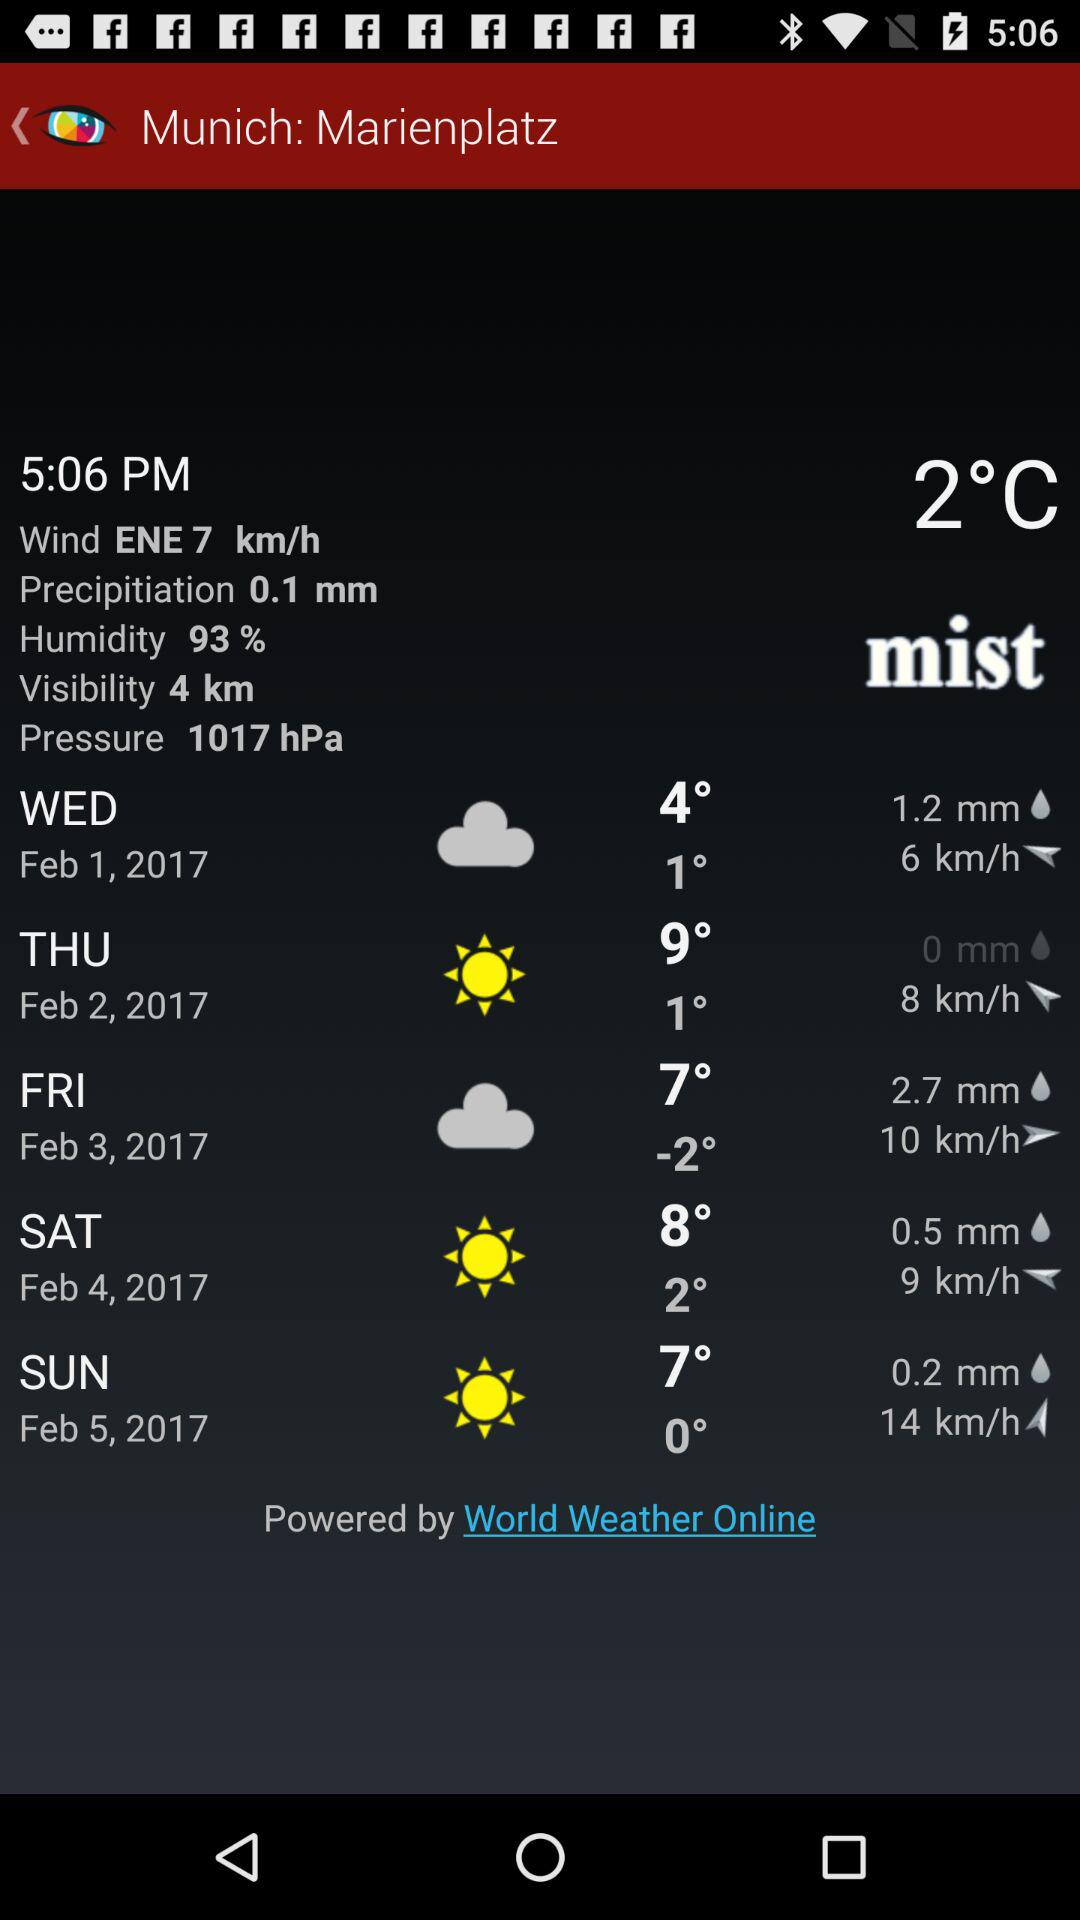What is the visibility? The visibility is 4 km. 